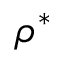<formula> <loc_0><loc_0><loc_500><loc_500>\rho ^ { * }</formula> 